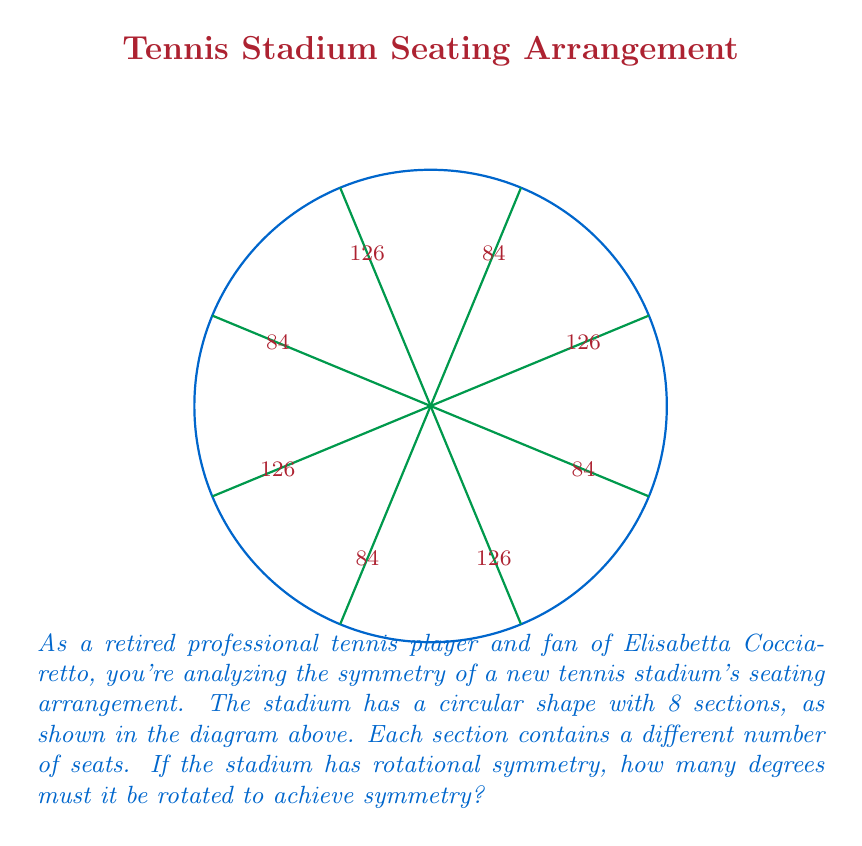Can you solve this math problem? To solve this problem, let's follow these steps:

1) First, we need to understand what rotational symmetry means. An object has rotational symmetry if it looks the same after a certain amount of rotation.

2) Look at the pattern of seat numbers in the sections:
   126, 84, 126, 84, 126, 84, 126, 84

3) We can see that this pattern repeats every two sections. This means the stadium has a rotational symmetry of order 4 (it repeats 4 times in a full rotation).

4) To calculate the degrees of rotation needed for symmetry, we use the formula:

   $$ \text{Degrees of rotation} = \frac{360°}{\text{Order of symmetry}} $$

5) Substituting our values:

   $$ \text{Degrees of rotation} = \frac{360°}{4} = 90° $$

Therefore, the stadium must be rotated 90° to achieve symmetry.
Answer: 90° 